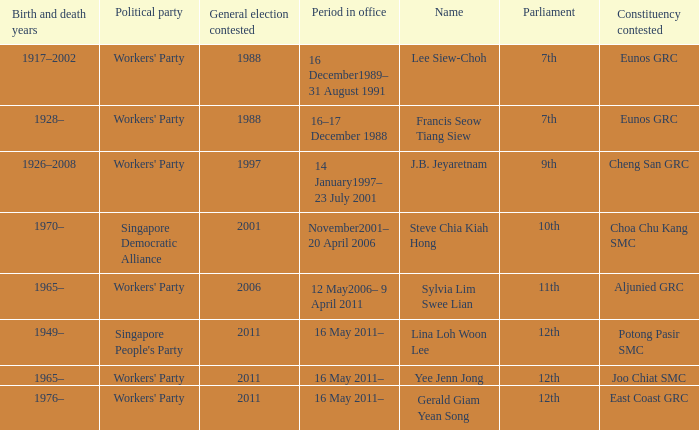Which parliament is sylvia lim swee lian? 11th. Give me the full table as a dictionary. {'header': ['Birth and death years', 'Political party', 'General election contested', 'Period in office', 'Name', 'Parliament', 'Constituency contested'], 'rows': [['1917–2002', "Workers' Party", '1988', '16 December1989– 31 August 1991', 'Lee Siew-Choh', '7th', 'Eunos GRC'], ['1928–', "Workers' Party", '1988', '16–17 December 1988', 'Francis Seow Tiang Siew', '7th', 'Eunos GRC'], ['1926–2008', "Workers' Party", '1997', '14 January1997– 23 July 2001', 'J.B. Jeyaretnam', '9th', 'Cheng San GRC'], ['1970–', 'Singapore Democratic Alliance', '2001', 'November2001– 20 April 2006', 'Steve Chia Kiah Hong', '10th', 'Choa Chu Kang SMC'], ['1965–', "Workers' Party", '2006', '12 May2006– 9 April 2011', 'Sylvia Lim Swee Lian', '11th', 'Aljunied GRC'], ['1949–', "Singapore People's Party", '2011', '16 May 2011–', 'Lina Loh Woon Lee', '12th', 'Potong Pasir SMC'], ['1965–', "Workers' Party", '2011', '16 May 2011–', 'Yee Jenn Jong', '12th', 'Joo Chiat SMC'], ['1976–', "Workers' Party", '2011', '16 May 2011–', 'Gerald Giam Yean Song', '12th', 'East Coast GRC']]} 